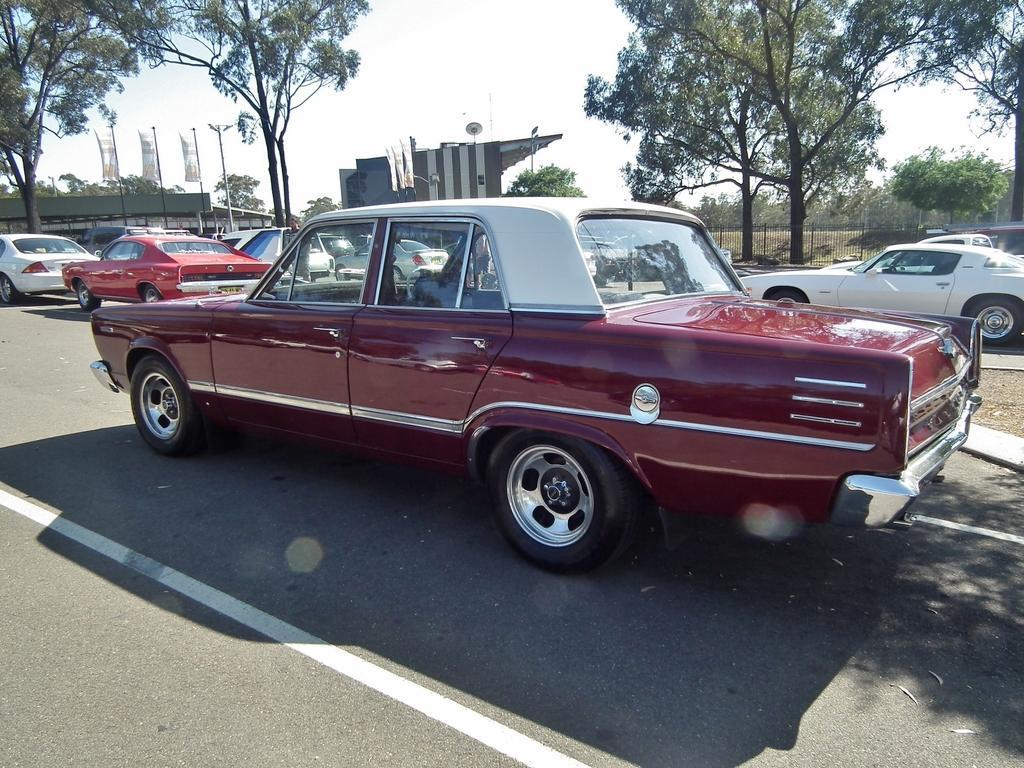In one or two sentences, can you explain what this image depicts? In this image there are few vehicles on the road, trees, buildings, railing and the sky. 